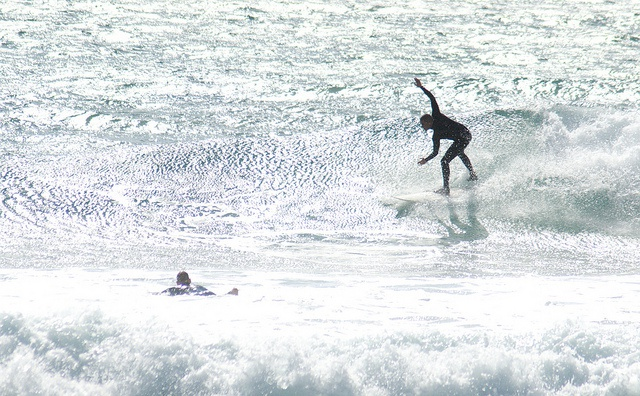Describe the objects in this image and their specific colors. I can see people in white, black, gray, and darkgray tones, people in white, darkgray, and gray tones, and surfboard in white, lightgray, and darkgray tones in this image. 